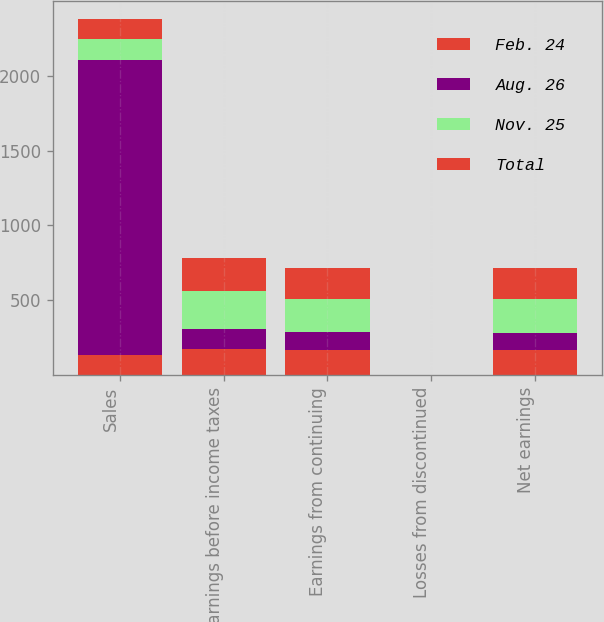Convert chart. <chart><loc_0><loc_0><loc_500><loc_500><stacked_bar_chart><ecel><fcel>Sales<fcel>Earnings before income taxes<fcel>Earnings from continuing<fcel>Losses from discontinued<fcel>Net earnings<nl><fcel>Feb. 24<fcel>135.3<fcel>176<fcel>168.9<fcel>0.02<fcel>166.2<nl><fcel>Aug. 26<fcel>1973.4<fcel>135.3<fcel>115.9<fcel>0.01<fcel>115.6<nl><fcel>Nov. 25<fcel>135.3<fcel>253.1<fcel>225.1<fcel>0.02<fcel>223.6<nl><fcel>Total<fcel>135.3<fcel>217.9<fcel>208.7<fcel>0.01<fcel>208<nl></chart> 